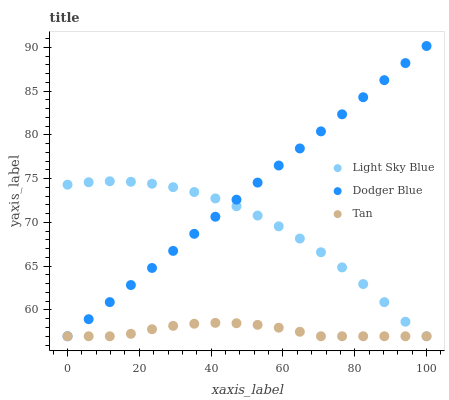Does Tan have the minimum area under the curve?
Answer yes or no. Yes. Does Dodger Blue have the maximum area under the curve?
Answer yes or no. Yes. Does Light Sky Blue have the minimum area under the curve?
Answer yes or no. No. Does Light Sky Blue have the maximum area under the curve?
Answer yes or no. No. Is Dodger Blue the smoothest?
Answer yes or no. Yes. Is Light Sky Blue the roughest?
Answer yes or no. Yes. Is Light Sky Blue the smoothest?
Answer yes or no. No. Is Dodger Blue the roughest?
Answer yes or no. No. Does Tan have the lowest value?
Answer yes or no. Yes. Does Dodger Blue have the highest value?
Answer yes or no. Yes. Does Light Sky Blue have the highest value?
Answer yes or no. No. Does Light Sky Blue intersect Tan?
Answer yes or no. Yes. Is Light Sky Blue less than Tan?
Answer yes or no. No. Is Light Sky Blue greater than Tan?
Answer yes or no. No. 